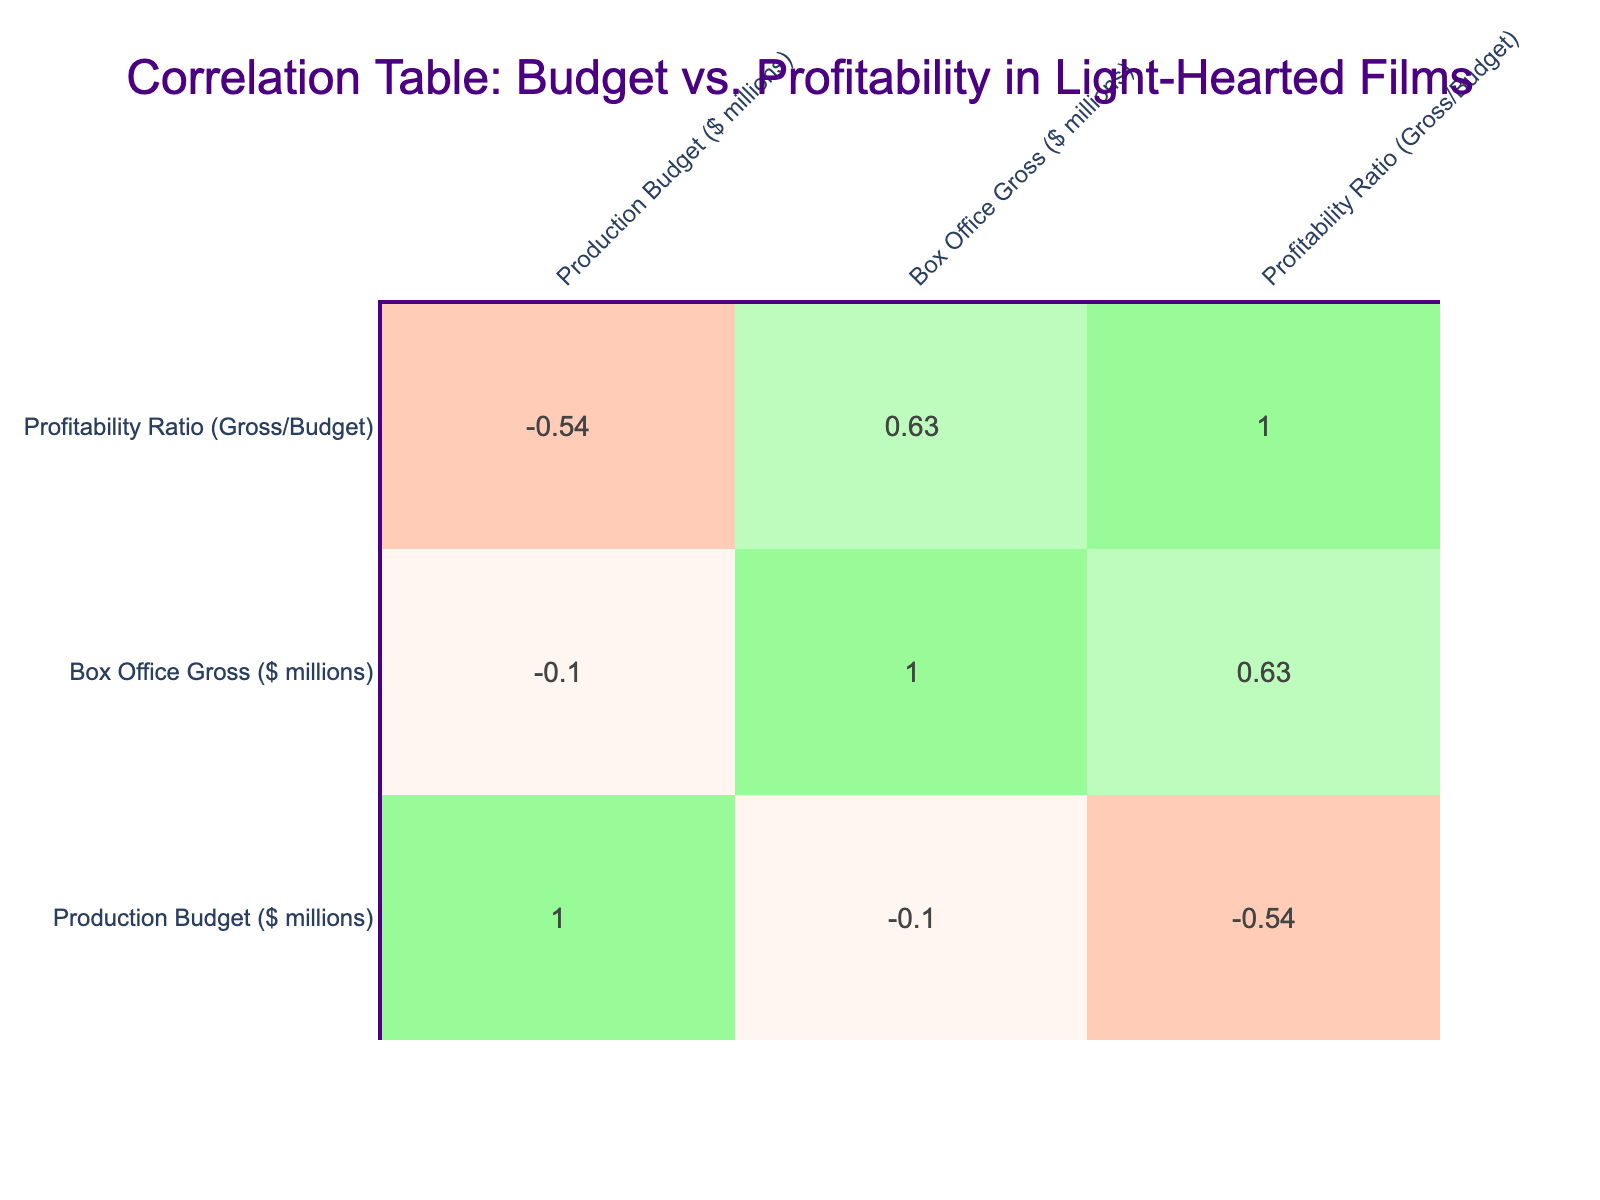What is the highest profitability ratio among the listed movies? Looking at the table, the profitability ratio for "The Hangover" is the highest at 13.36.
Answer: 13.36 Which movie has the lowest box office gross? From the table, "Napoleon Dynamite" has the lowest box office gross of 46 million dollars.
Answer: 46 What is the average production budget for all the comedies listed? Adding the production budgets for all comedy films: 25 + 20 + 32 + 28 + 35 + 94 + 28 + 17 + 400 = 659. There are 9 comedy films, so the average budget is 659 / 9 ≈ 73.22 million dollars.
Answer: 73.22 Is there a correlation between production budget and box office gross? Yes, the correlation value is positive, indicating that as the production budget increases, the box office gross tends to increase.
Answer: Yes Which comedy had a profitability ratio below 2? Upon checking, "Zoolander" has a profitability ratio of 2.14, while "Napoleon Dynamite" has a profitability ratio of 0.12, which is below 2.
Answer: Napoleon Dynamite What is the total box office gross for productions with a budget of over 90 million? From the table, there are two movies: "Finding Nemo" with a gross of 940 million and "Tropic Thunder" with a gross of 195 million. Adding these together gives 940 + 195 = 1135 million dollars.
Answer: 1135 Are there any romantic comedies in the top three highest profitability ratios? The top three highest profitability ratios are 13.36 (The Hangover), 10.00 (Finding Nemo), and 9.00 (Bridesmaids). "Groundhog Day" is the only romantic comedy on the list and it does not appear in the top three.
Answer: No What is the difference in profitability ratio between the highest and lowest on the list? The highest profitability ratio is 13.36 (The Hangover) and the lowest is 0.12 (Napoleon Dynamite), so the difference is 13.36 - 0.12 = 13.24.
Answer: 13.24 